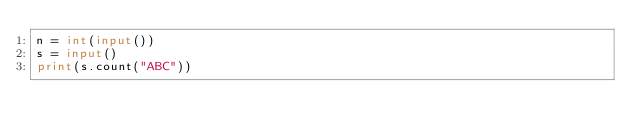<code> <loc_0><loc_0><loc_500><loc_500><_Python_>n = int(input())
s = input()
print(s.count("ABC"))
</code> 